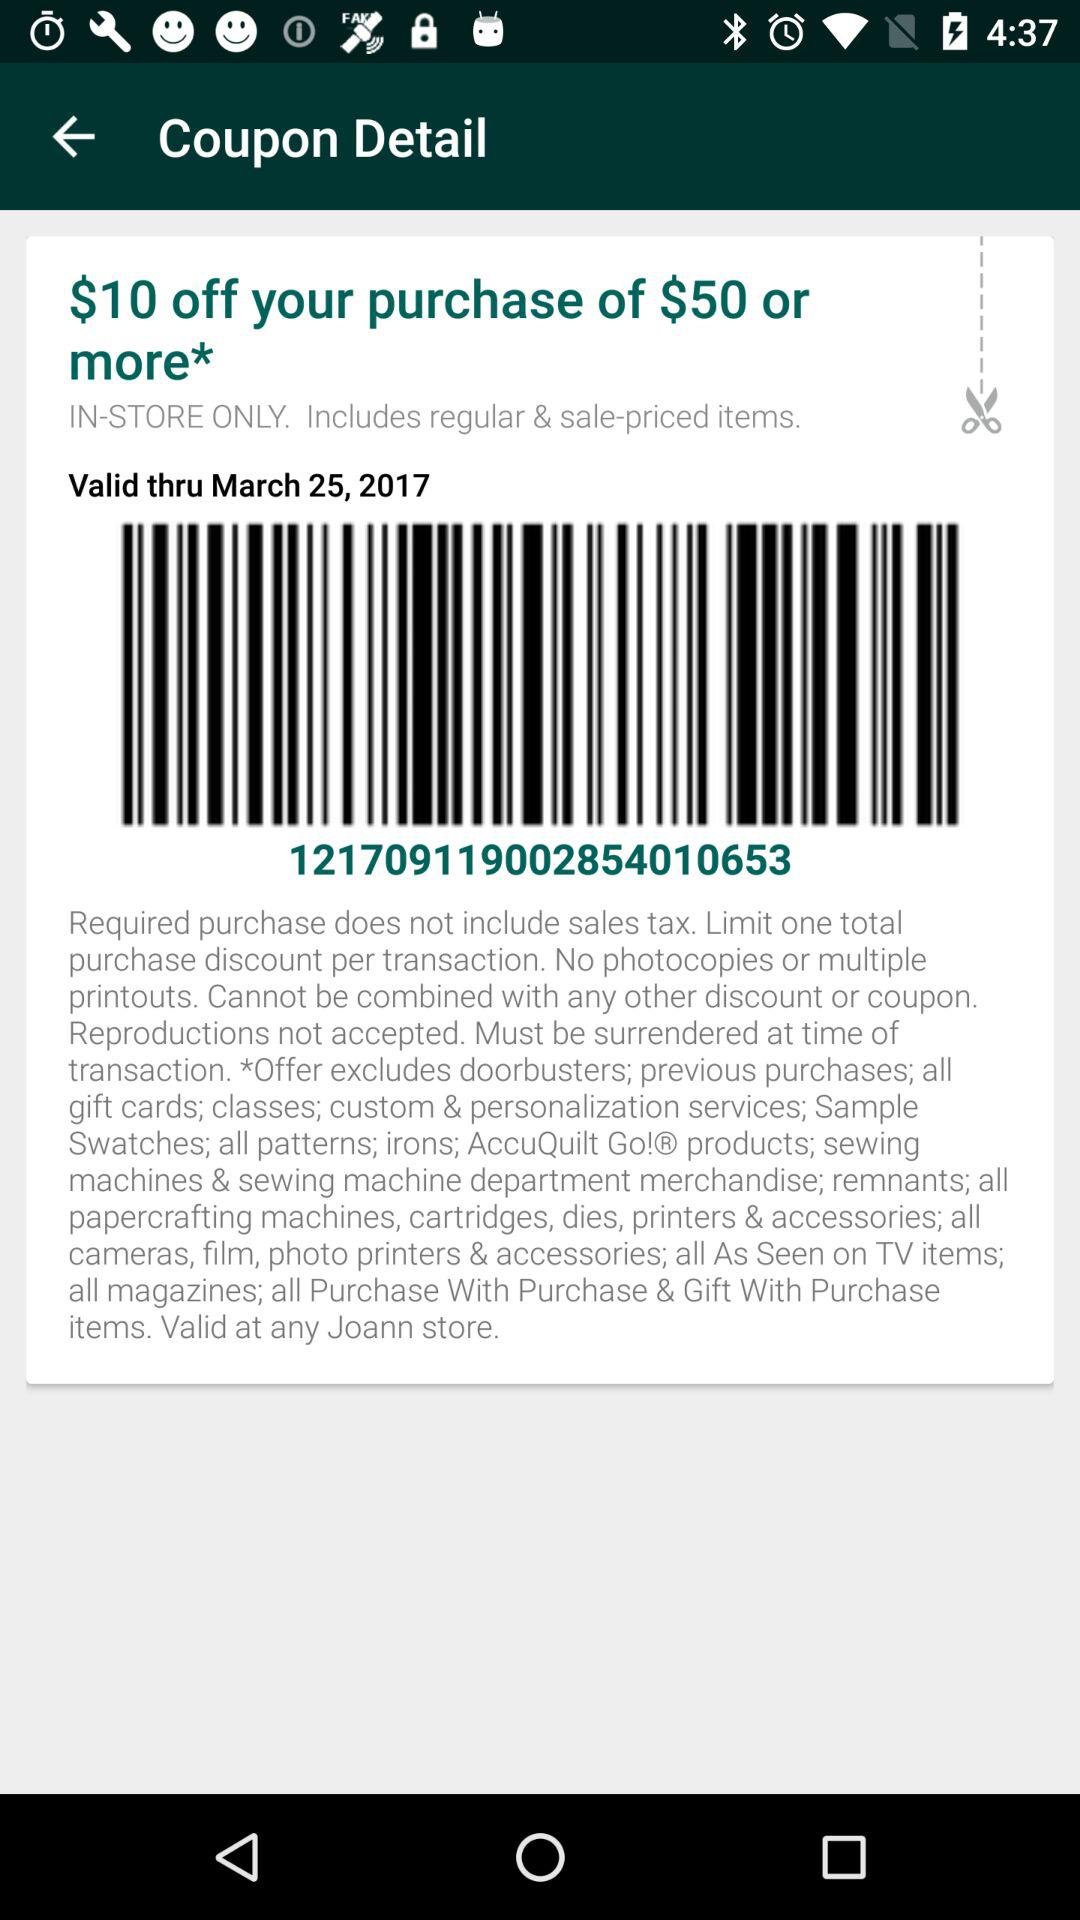What is the expiration date of this coupon?
Answer the question using a single word or phrase. March 25, 2017 